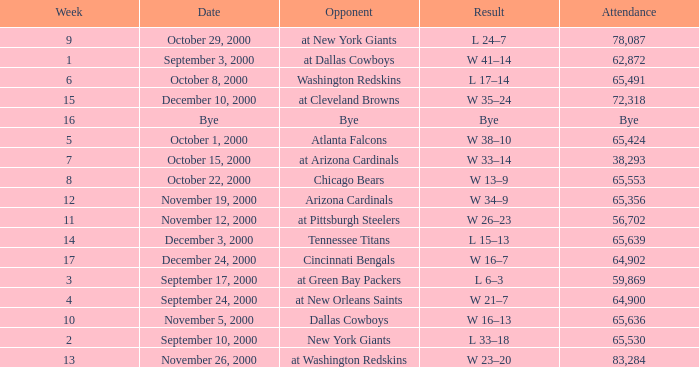What was the attendance when the Cincinnati Bengals were the opponents? 64902.0. 